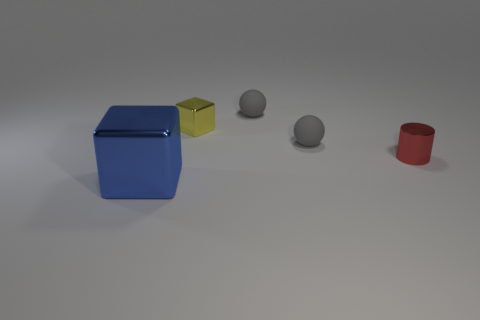Subtract 2 spheres. How many spheres are left? 0 Subtract all purple cylinders. Subtract all blue blocks. How many cylinders are left? 1 Subtract all gray spheres. How many brown cubes are left? 0 Subtract all big metallic objects. Subtract all small red things. How many objects are left? 3 Add 2 big metal cubes. How many big metal cubes are left? 3 Add 4 green metal cubes. How many green metal cubes exist? 4 Add 4 red things. How many objects exist? 9 Subtract 0 gray blocks. How many objects are left? 5 Subtract all cylinders. How many objects are left? 4 